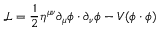<formula> <loc_0><loc_0><loc_500><loc_500>{ \mathcal { L } } = { \frac { 1 } { 2 } } \eta ^ { \mu \nu } \partial _ { \mu } \phi \cdot \partial _ { \nu } \phi - V ( \phi \cdot \phi )</formula> 